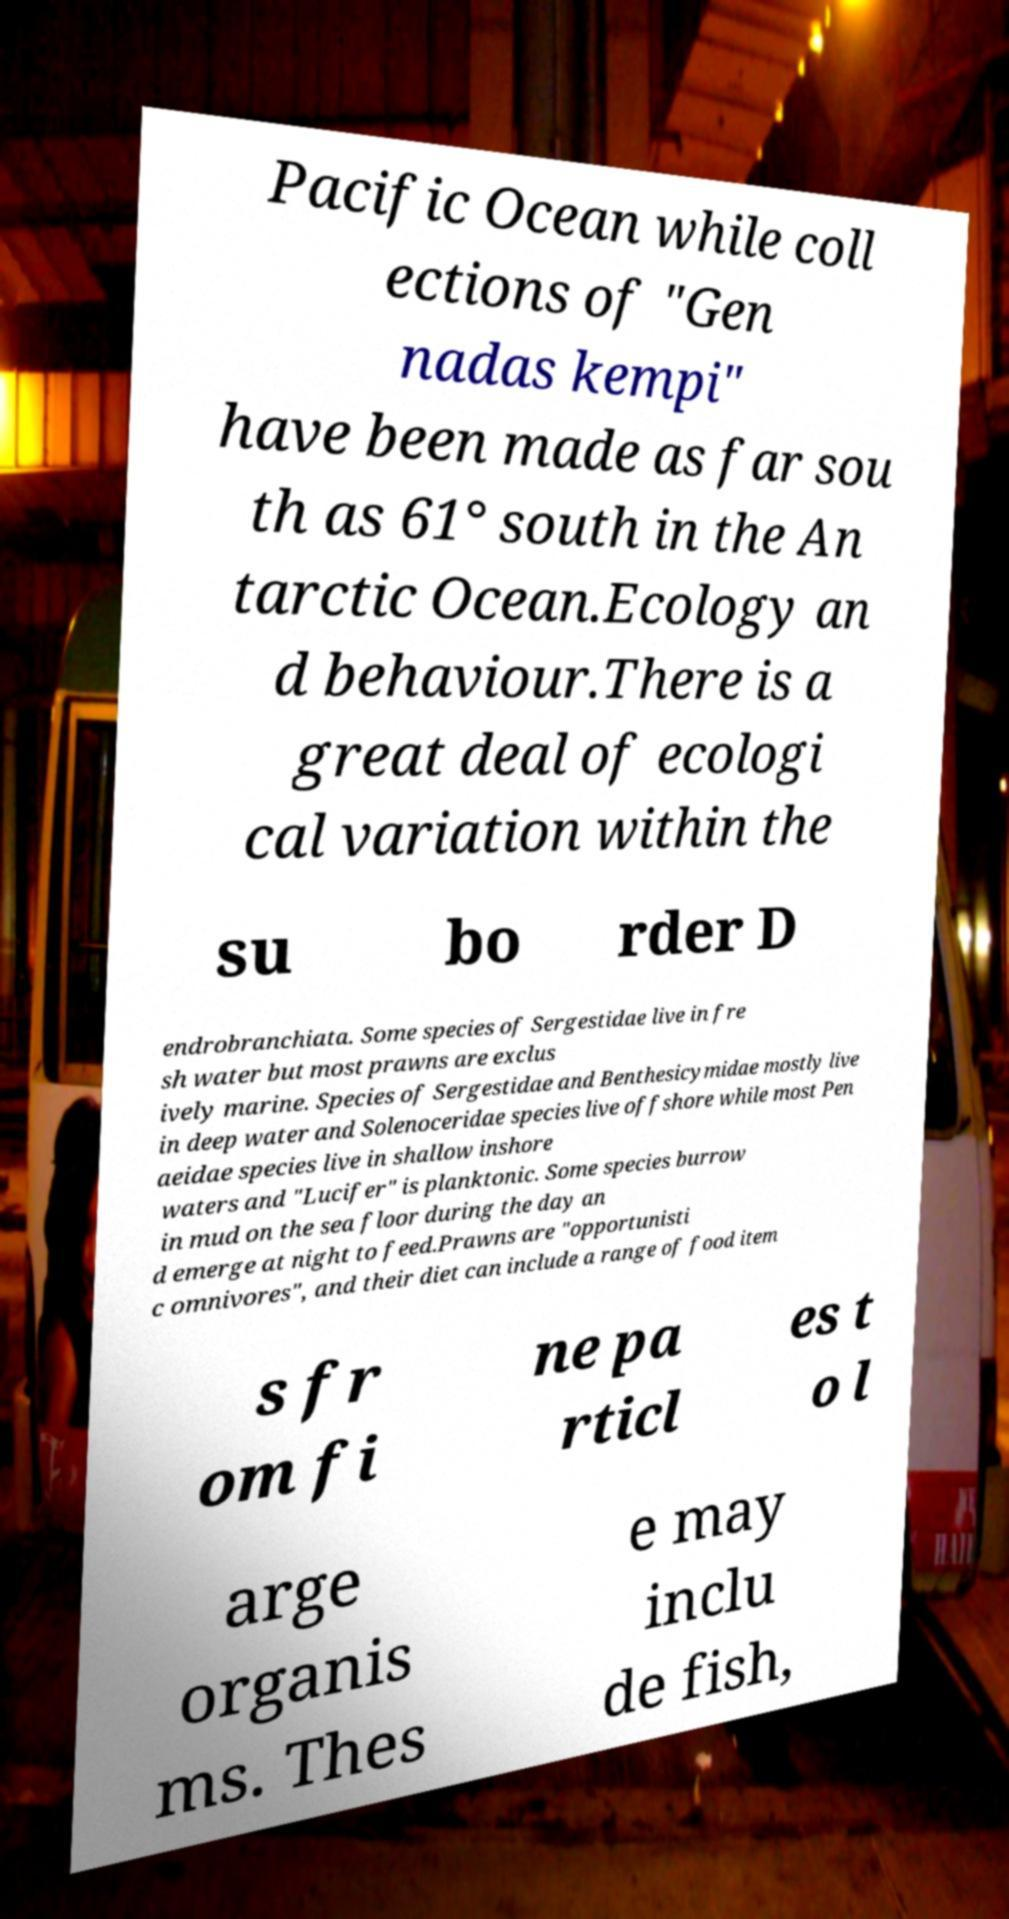For documentation purposes, I need the text within this image transcribed. Could you provide that? Pacific Ocean while coll ections of "Gen nadas kempi" have been made as far sou th as 61° south in the An tarctic Ocean.Ecology an d behaviour.There is a great deal of ecologi cal variation within the su bo rder D endrobranchiata. Some species of Sergestidae live in fre sh water but most prawns are exclus ively marine. Species of Sergestidae and Benthesicymidae mostly live in deep water and Solenoceridae species live offshore while most Pen aeidae species live in shallow inshore waters and "Lucifer" is planktonic. Some species burrow in mud on the sea floor during the day an d emerge at night to feed.Prawns are "opportunisti c omnivores", and their diet can include a range of food item s fr om fi ne pa rticl es t o l arge organis ms. Thes e may inclu de fish, 